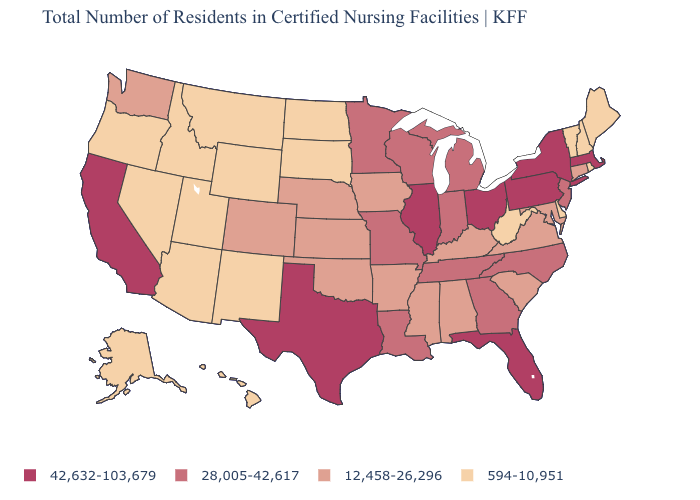Does the first symbol in the legend represent the smallest category?
Write a very short answer. No. Does Missouri have the highest value in the MidWest?
Answer briefly. No. Which states have the highest value in the USA?
Give a very brief answer. California, Florida, Illinois, Massachusetts, New York, Ohio, Pennsylvania, Texas. Which states hav the highest value in the MidWest?
Keep it brief. Illinois, Ohio. Which states hav the highest value in the West?
Quick response, please. California. What is the highest value in the South ?
Write a very short answer. 42,632-103,679. Name the states that have a value in the range 594-10,951?
Keep it brief. Alaska, Arizona, Delaware, Hawaii, Idaho, Maine, Montana, Nevada, New Hampshire, New Mexico, North Dakota, Oregon, Rhode Island, South Dakota, Utah, Vermont, West Virginia, Wyoming. What is the value of Kansas?
Be succinct. 12,458-26,296. Does the map have missing data?
Concise answer only. No. Does California have the highest value in the West?
Short answer required. Yes. Does Texas have the highest value in the South?
Give a very brief answer. Yes. Which states have the highest value in the USA?
Keep it brief. California, Florida, Illinois, Massachusetts, New York, Ohio, Pennsylvania, Texas. Does Missouri have the same value as Minnesota?
Short answer required. Yes. What is the highest value in the USA?
Concise answer only. 42,632-103,679. Among the states that border Wisconsin , which have the highest value?
Be succinct. Illinois. 